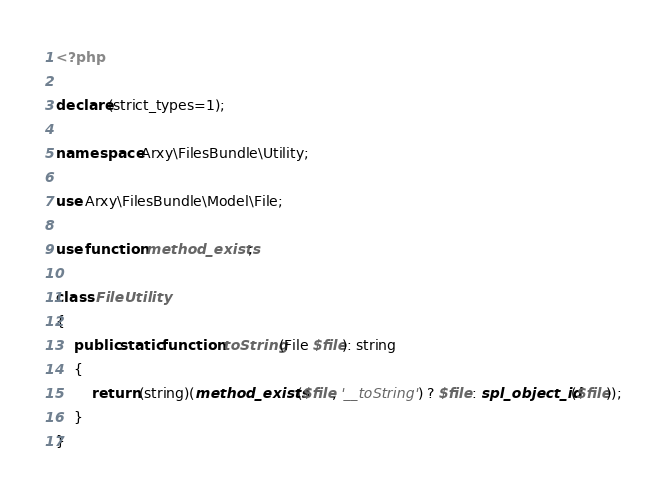Convert code to text. <code><loc_0><loc_0><loc_500><loc_500><_PHP_><?php

declare(strict_types=1);

namespace Arxy\FilesBundle\Utility;

use Arxy\FilesBundle\Model\File;

use function method_exists;

class FileUtility
{
    public static function toString(File $file): string
    {
        return (string)(method_exists($file, '__toString') ? $file : spl_object_id($file));
    }
}
</code> 